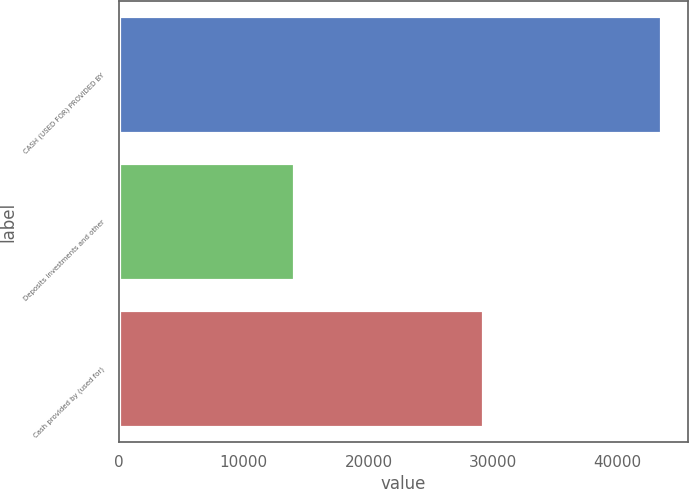Convert chart to OTSL. <chart><loc_0><loc_0><loc_500><loc_500><bar_chart><fcel>CASH (USED FOR) PROVIDED BY<fcel>Deposits investments and other<fcel>Cash provided by (used for)<nl><fcel>43453<fcel>14017<fcel>29176<nl></chart> 